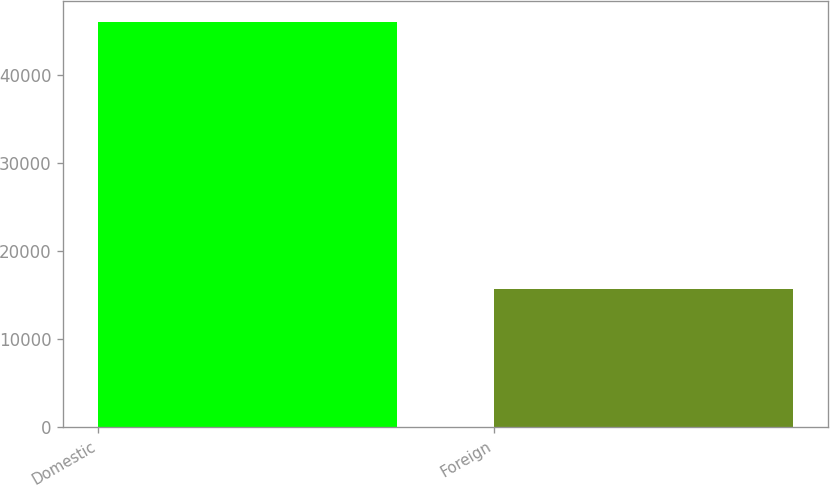Convert chart to OTSL. <chart><loc_0><loc_0><loc_500><loc_500><bar_chart><fcel>Domestic<fcel>Foreign<nl><fcel>46018<fcel>15643<nl></chart> 